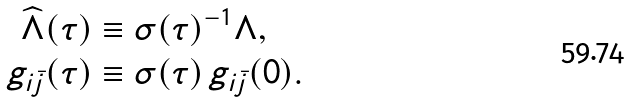Convert formula to latex. <formula><loc_0><loc_0><loc_500><loc_500>\widehat { \Lambda } ( \tau ) & \equiv \sigma ( \tau ) ^ { - 1 } \Lambda , \\ g _ { i \bar { j } } ( \tau ) & \equiv \sigma ( \tau ) \, g _ { i \bar { j } } ( 0 ) .</formula> 